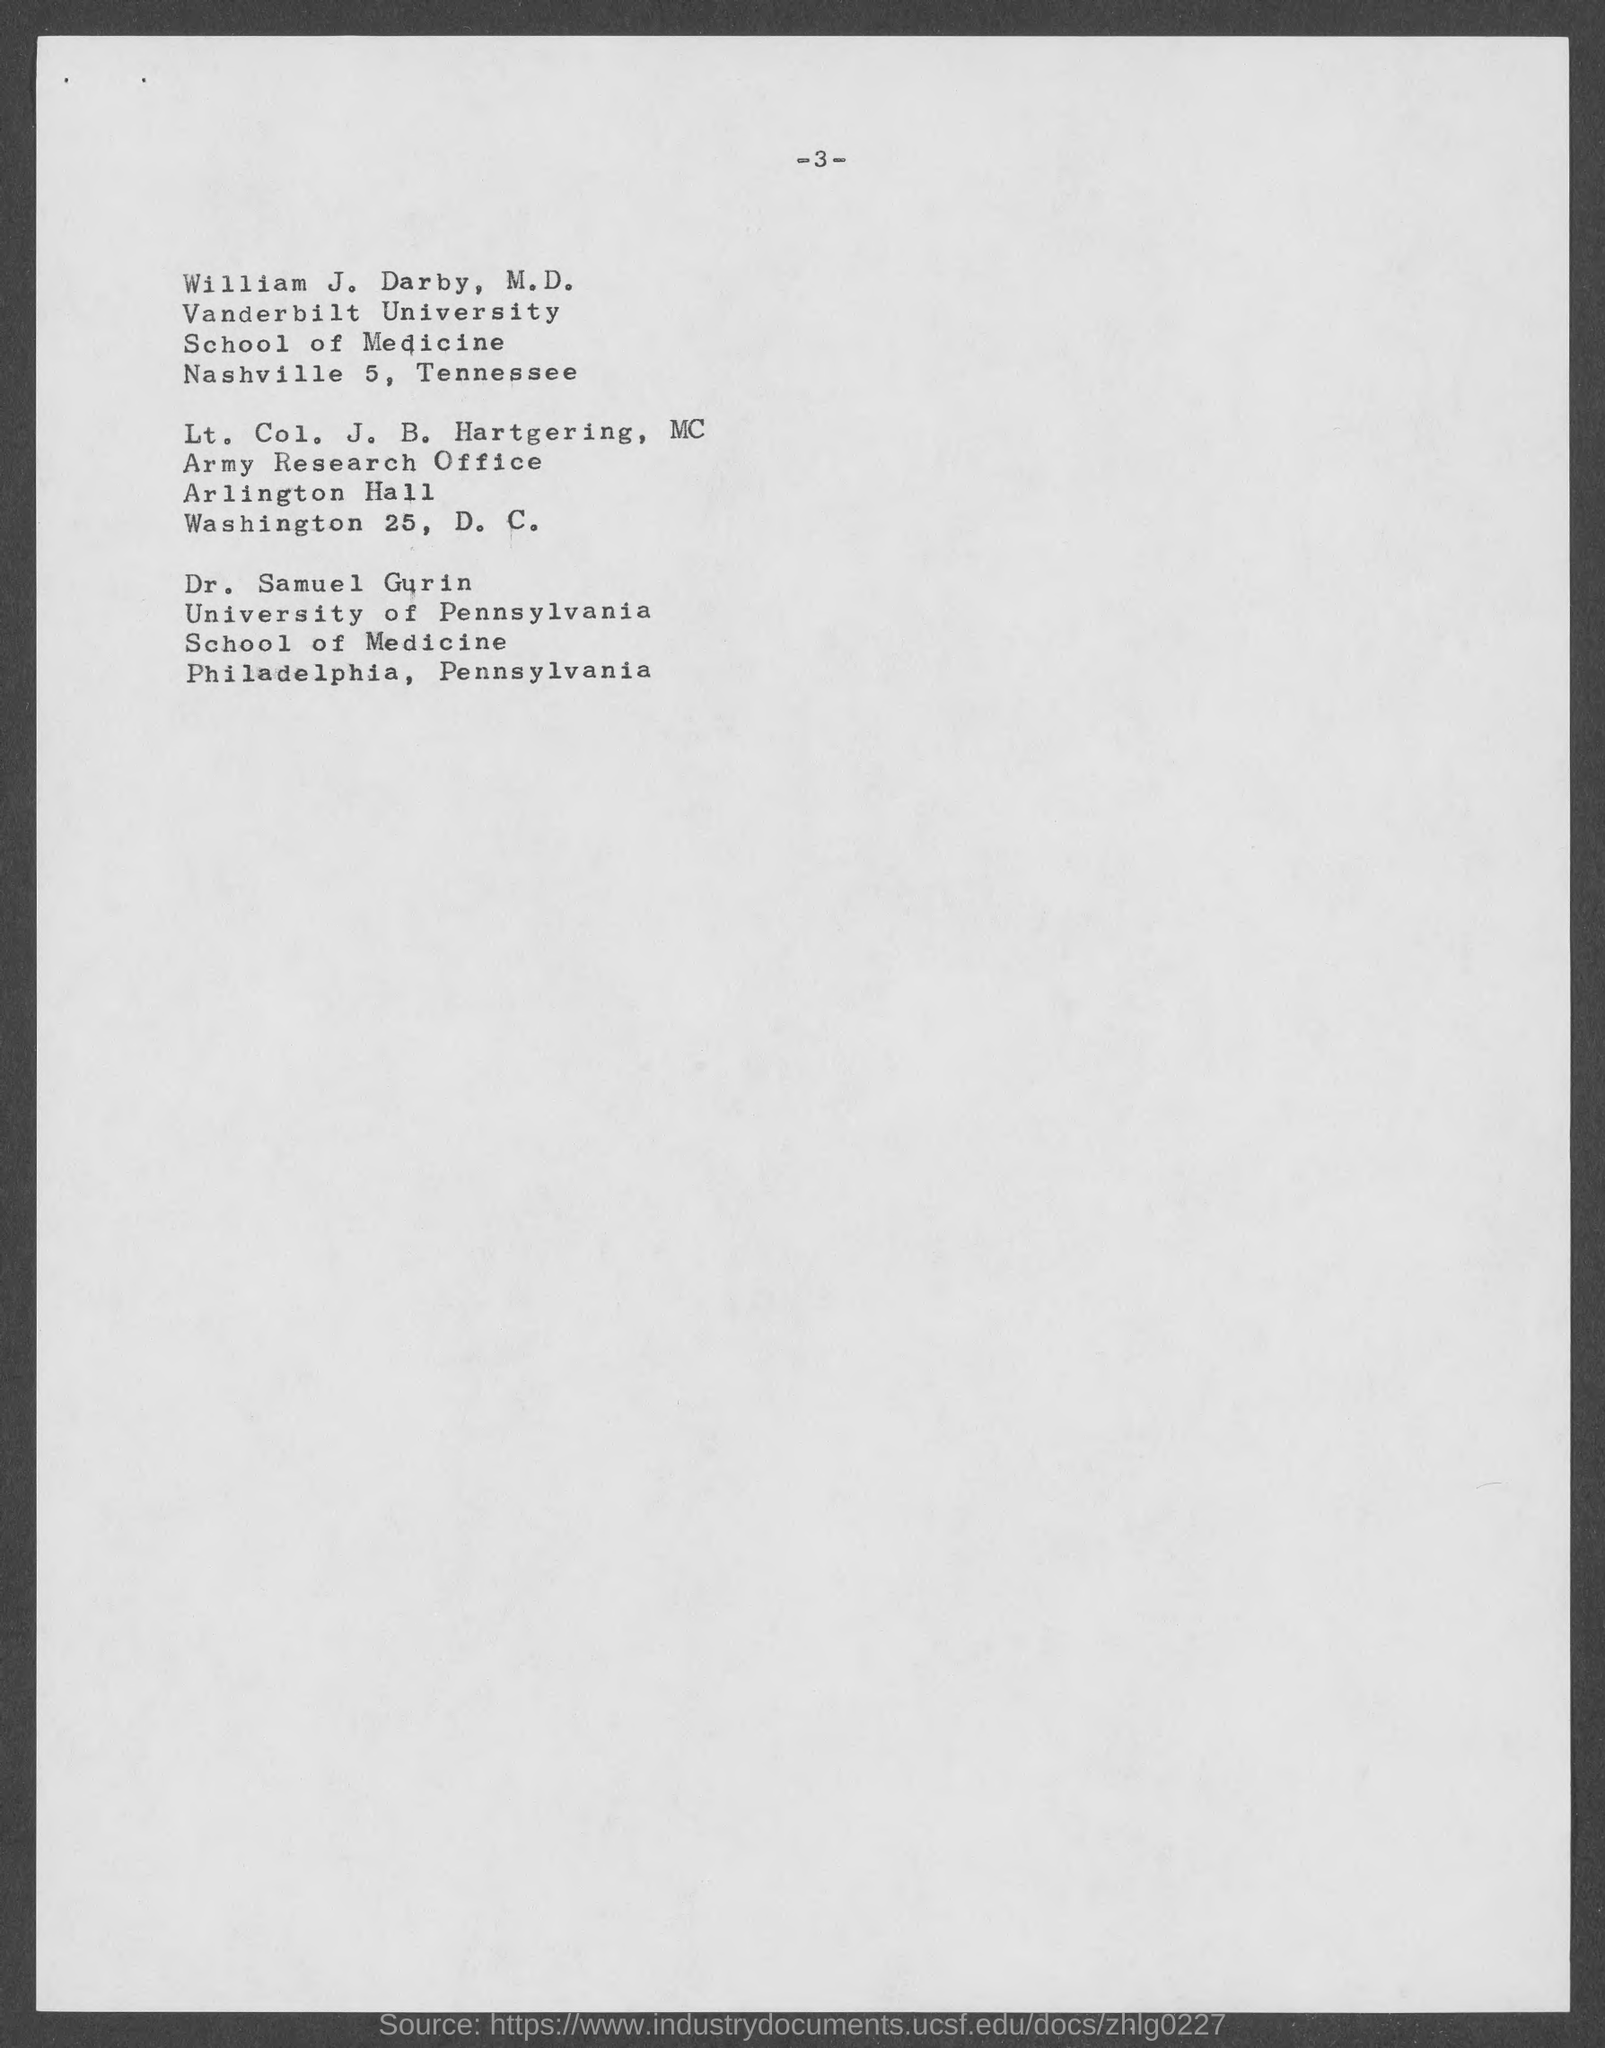What is the page number at top of the page?
Offer a terse response. 3. To which university does william j. darby belong ?
Provide a short and direct response. Vanderbilt University. To which university does dr. samuel gurin belong ?
Your answer should be very brief. University of pennsylvania. 